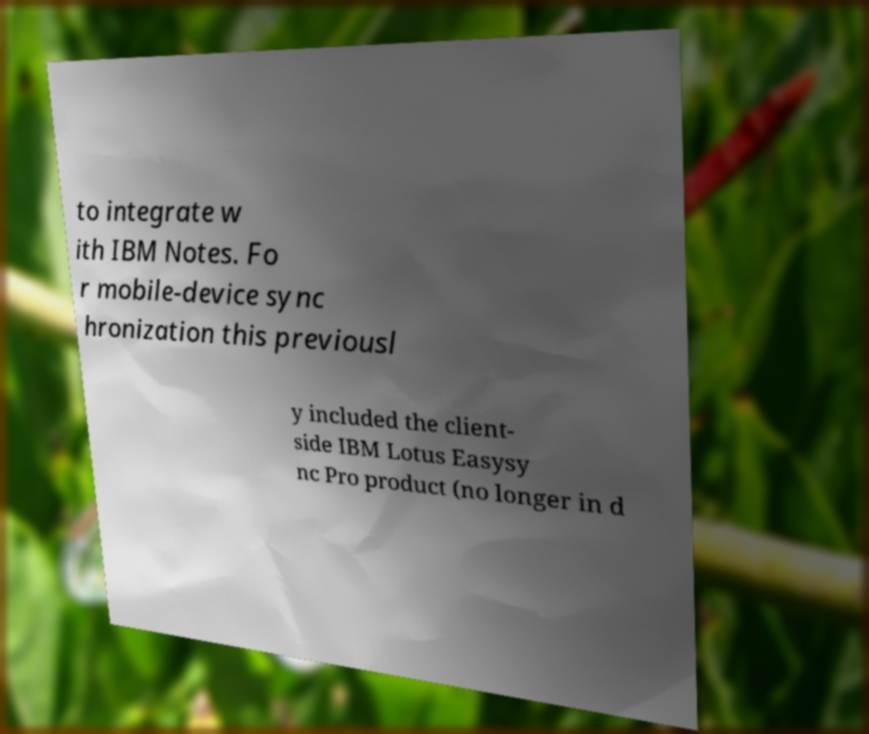Could you extract and type out the text from this image? to integrate w ith IBM Notes. Fo r mobile-device sync hronization this previousl y included the client- side IBM Lotus Easysy nc Pro product (no longer in d 